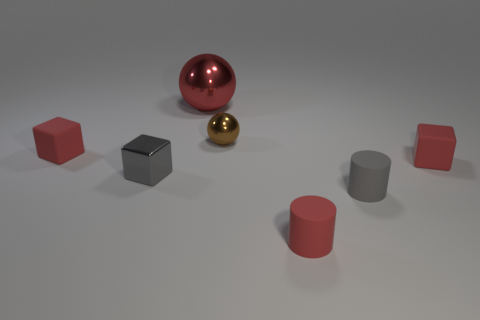What number of small gray cylinders have the same material as the tiny ball?
Your answer should be compact. 0. There is a small gray matte object; is it the same shape as the gray object left of the red sphere?
Give a very brief answer. No. Are there any matte cylinders that are behind the small rubber cube that is in front of the tiny rubber object left of the tiny brown metallic object?
Your answer should be compact. No. How big is the rubber object that is on the left side of the small sphere?
Your answer should be compact. Small. What material is the gray cylinder that is the same size as the gray shiny block?
Your answer should be compact. Rubber. Do the gray shiny thing and the big red thing have the same shape?
Your response must be concise. No. What number of things are red balls or tiny red things to the right of the gray matte cylinder?
Keep it short and to the point. 2. There is a small cylinder that is the same color as the metal cube; what material is it?
Offer a terse response. Rubber. Does the rubber cube right of the metallic cube have the same size as the small gray rubber thing?
Your answer should be compact. Yes. How many tiny matte objects are in front of the rubber cube to the right of the small red rubber thing that is left of the red cylinder?
Keep it short and to the point. 2. 